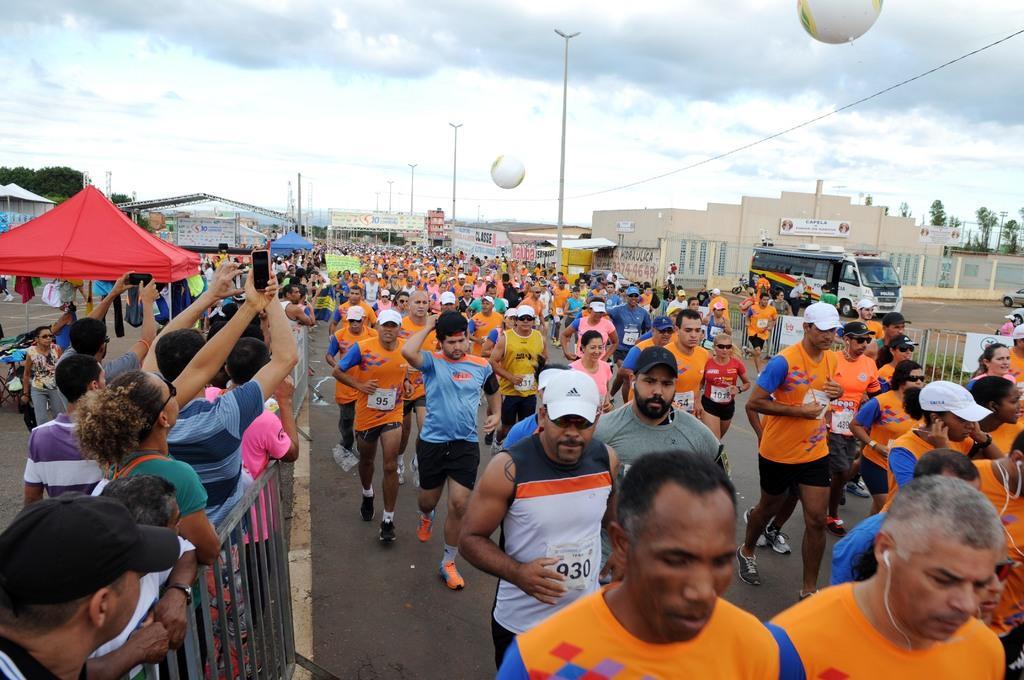Could you give a brief overview of what you see in this image? In this image on the right side there are persons running, there are cars and there is a fence. On the left side there are persons standing and there are tents which are red and blue in colour. In the background there are buildings, trees and the sky is cloudy and there are poles and there are balloons in the sky. 